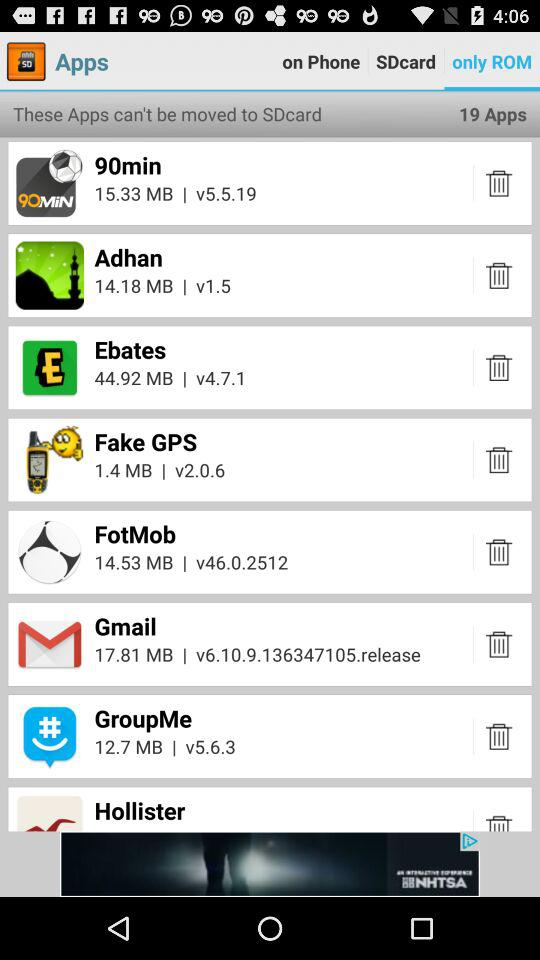How many total application are there? There are 19 applications in total. 